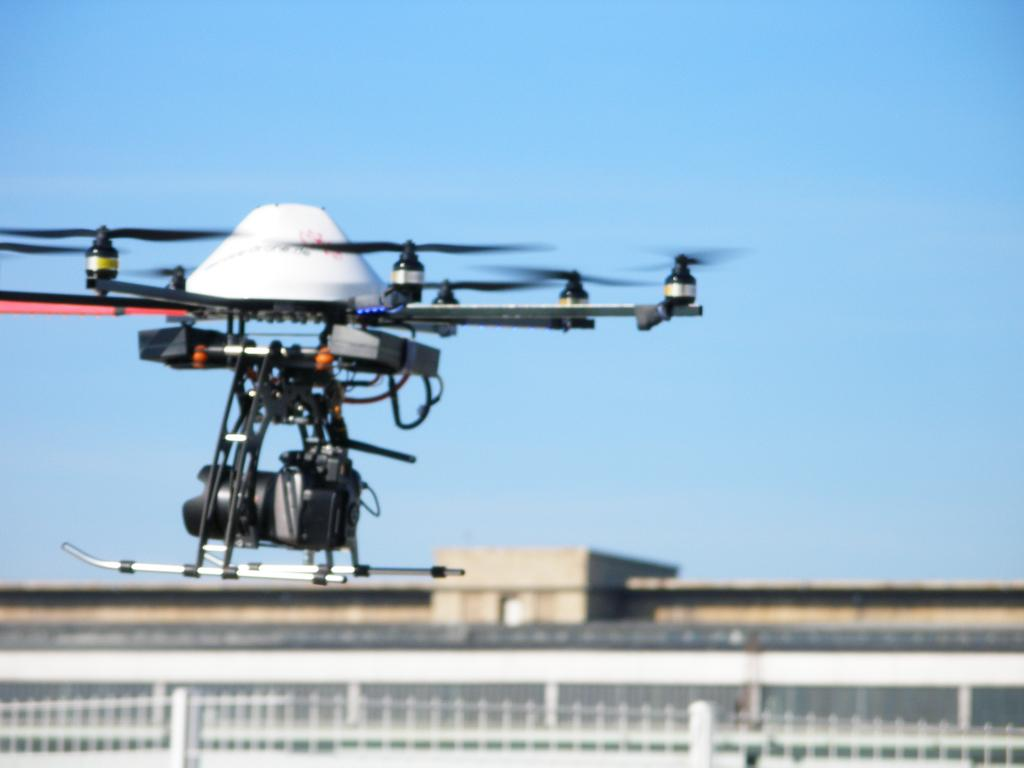What is flying in the air in the image? There is a drone in the air in the image. What can be seen on the ground in the image? There is a fence in the image. What else is present in the image besides the drone and fence? There are some objects in the image. What is visible in the distance in the image? The sky is visible in the background of the image. Reasoning: Let' Let's think step by step in order to produce the conversation. We start by identifying the main subject in the image, which is the drone flying in the air. Then, we describe the ground-level elements, such as the fence. Next, we mention the presence of other objects in the image. Finally, we acknowledge the sky visible in the background. Each question is designed to elicit a specific detail about the image that is known from the provided facts. Absurd Question/Answer: What type of treatment is the drone receiving in the image? There is no indication in the image that the drone is receiving any treatment; it is simply flying in the air. What type of treatment is the drone receiving in the image? There is no indication in the image that the drone is receiving any treatment; it is simply flying in the air. 